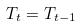Convert formula to latex. <formula><loc_0><loc_0><loc_500><loc_500>T _ { t } = T _ { t - 1 }</formula> 